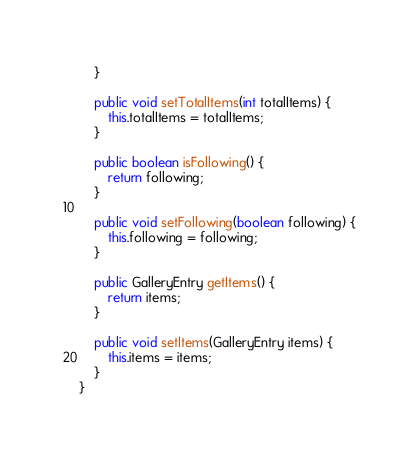Convert code to text. <code><loc_0><loc_0><loc_500><loc_500><_Java_>    }

    public void setTotalItems(int totalItems) {
        this.totalItems = totalItems;
    }

    public boolean isFollowing() {
        return following;
    }

    public void setFollowing(boolean following) {
        this.following = following;
    }

    public GalleryEntry getItems() {
        return items;
    }

    public void setItems(GalleryEntry items) {
        this.items = items;
    }
}
</code> 